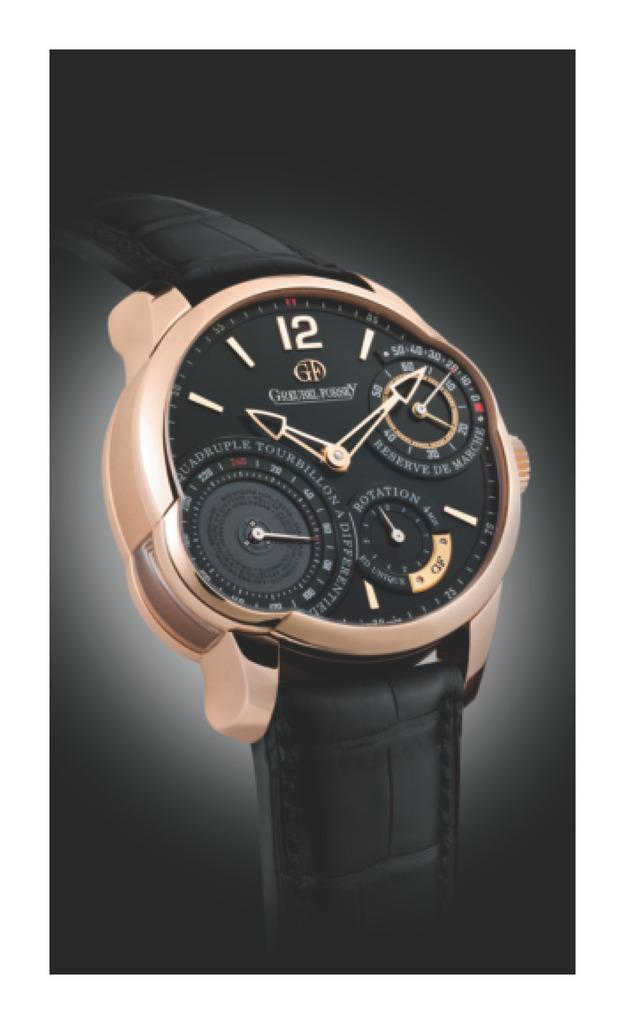<image>
Offer a succinct explanation of the picture presented. A black watch has the number 12 on it's face. 